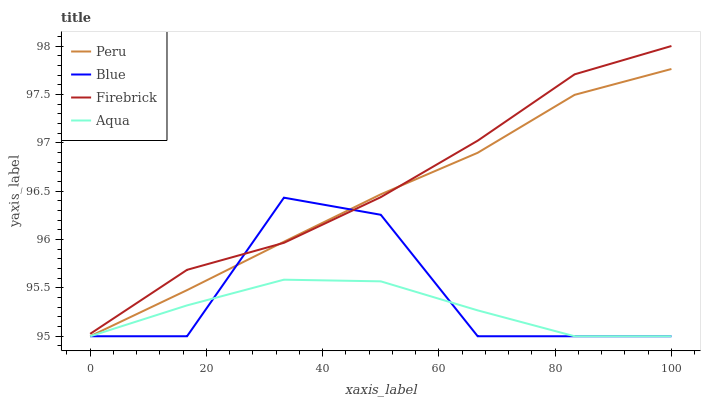Does Aqua have the minimum area under the curve?
Answer yes or no. Yes. Does Firebrick have the maximum area under the curve?
Answer yes or no. Yes. Does Firebrick have the minimum area under the curve?
Answer yes or no. No. Does Aqua have the maximum area under the curve?
Answer yes or no. No. Is Peru the smoothest?
Answer yes or no. Yes. Is Blue the roughest?
Answer yes or no. Yes. Is Firebrick the smoothest?
Answer yes or no. No. Is Firebrick the roughest?
Answer yes or no. No. Does Blue have the lowest value?
Answer yes or no. Yes. Does Firebrick have the lowest value?
Answer yes or no. No. Does Firebrick have the highest value?
Answer yes or no. Yes. Does Aqua have the highest value?
Answer yes or no. No. Is Aqua less than Firebrick?
Answer yes or no. Yes. Is Firebrick greater than Aqua?
Answer yes or no. Yes. Does Blue intersect Firebrick?
Answer yes or no. Yes. Is Blue less than Firebrick?
Answer yes or no. No. Is Blue greater than Firebrick?
Answer yes or no. No. Does Aqua intersect Firebrick?
Answer yes or no. No. 